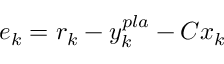<formula> <loc_0><loc_0><loc_500><loc_500>e _ { k } = r _ { k } - y _ { k } ^ { p l a } - C x _ { k }</formula> 